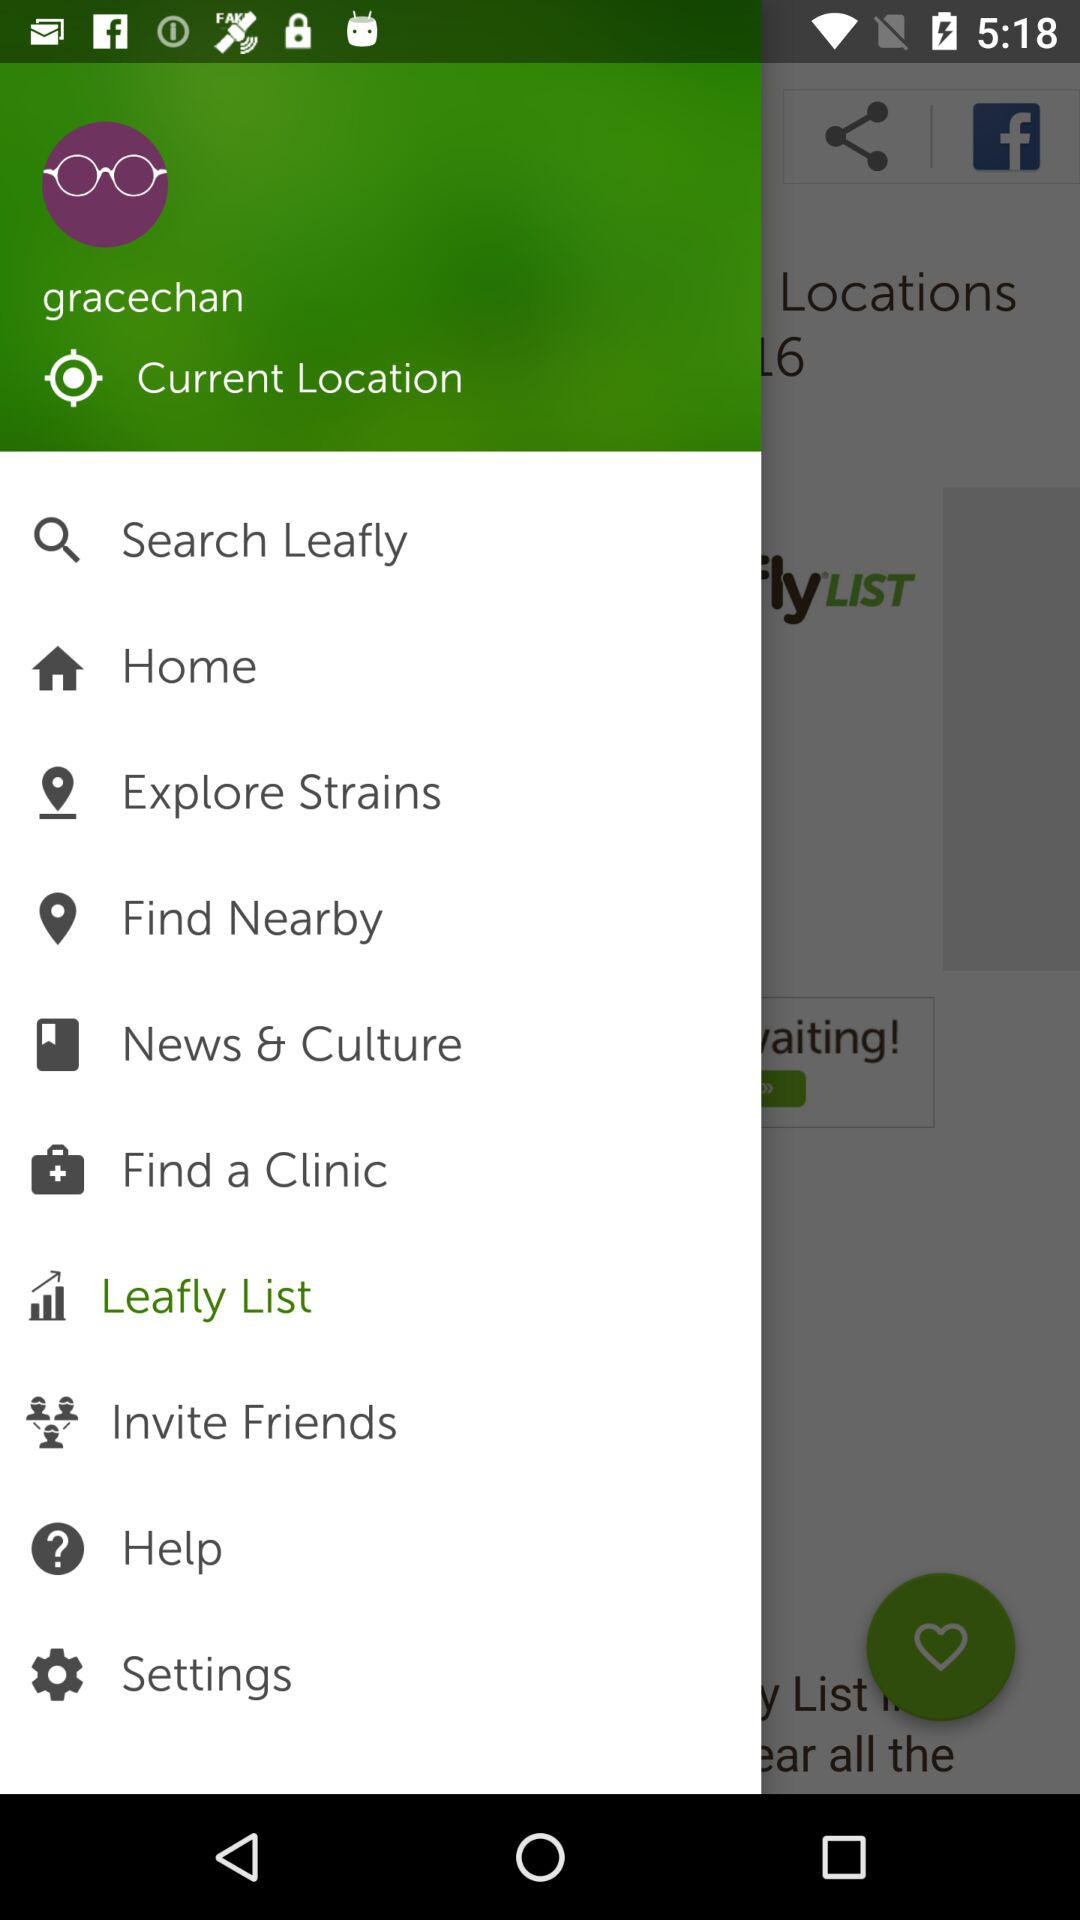What is the username given? The username is "gracechan". 